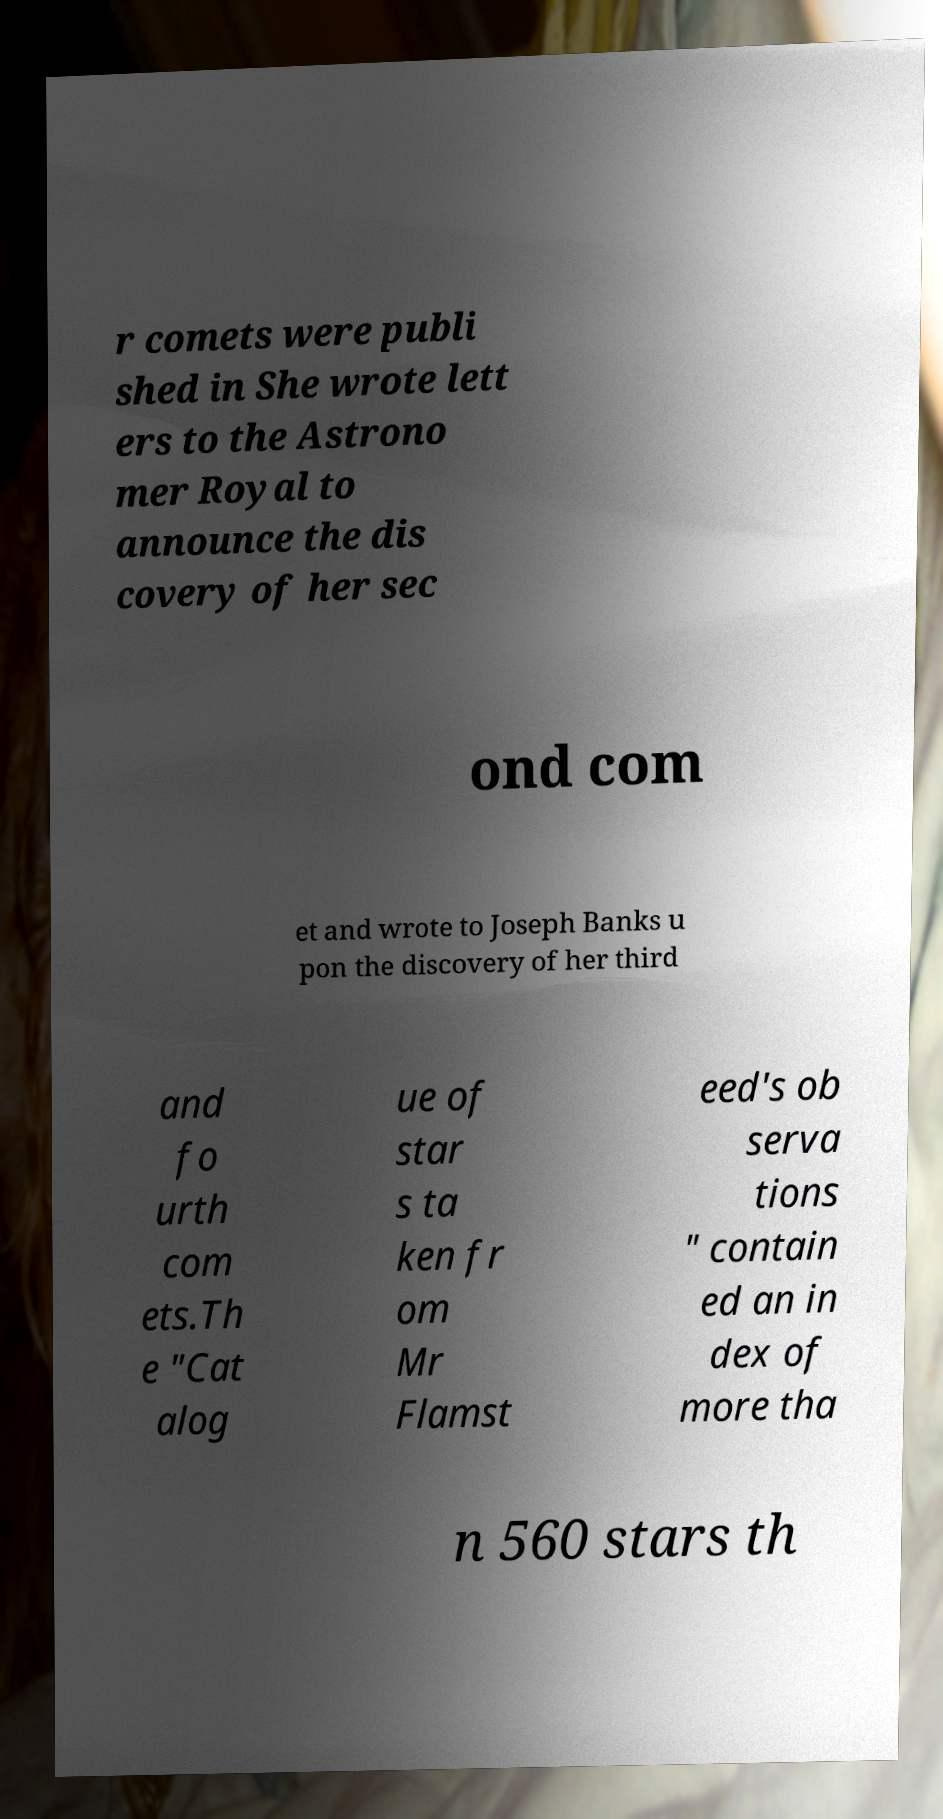Could you assist in decoding the text presented in this image and type it out clearly? r comets were publi shed in She wrote lett ers to the Astrono mer Royal to announce the dis covery of her sec ond com et and wrote to Joseph Banks u pon the discovery of her third and fo urth com ets.Th e "Cat alog ue of star s ta ken fr om Mr Flamst eed's ob serva tions " contain ed an in dex of more tha n 560 stars th 